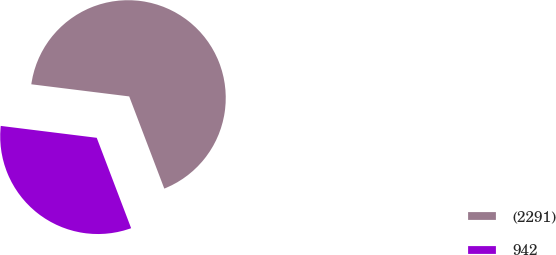<chart> <loc_0><loc_0><loc_500><loc_500><pie_chart><fcel>(2291)<fcel>942<nl><fcel>67.25%<fcel>32.75%<nl></chart> 